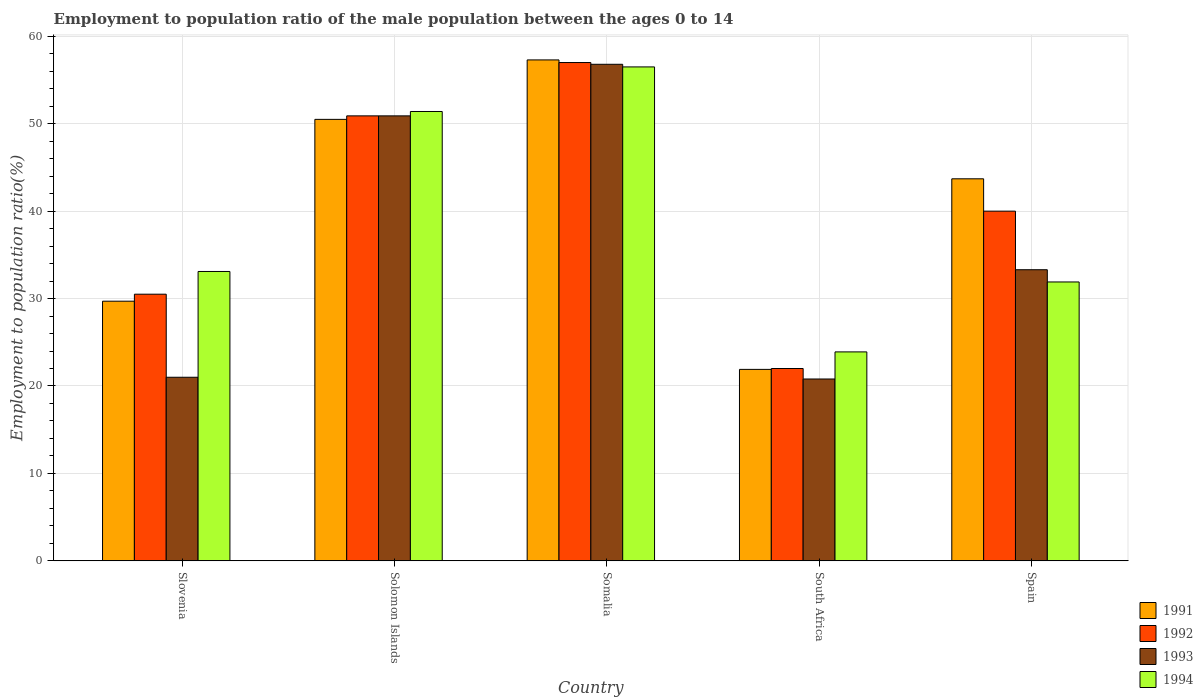Are the number of bars on each tick of the X-axis equal?
Keep it short and to the point. Yes. What is the label of the 1st group of bars from the left?
Ensure brevity in your answer.  Slovenia. Across all countries, what is the maximum employment to population ratio in 1992?
Your response must be concise. 57. Across all countries, what is the minimum employment to population ratio in 1992?
Provide a succinct answer. 22. In which country was the employment to population ratio in 1993 maximum?
Give a very brief answer. Somalia. In which country was the employment to population ratio in 1993 minimum?
Make the answer very short. South Africa. What is the total employment to population ratio in 1994 in the graph?
Provide a succinct answer. 196.8. What is the difference between the employment to population ratio in 1993 in Somalia and that in Spain?
Keep it short and to the point. 23.5. What is the difference between the employment to population ratio in 1993 in Solomon Islands and the employment to population ratio in 1992 in South Africa?
Your response must be concise. 28.9. What is the average employment to population ratio in 1993 per country?
Your response must be concise. 36.56. What is the difference between the employment to population ratio of/in 1991 and employment to population ratio of/in 1993 in Solomon Islands?
Ensure brevity in your answer.  -0.4. In how many countries, is the employment to population ratio in 1992 greater than 52 %?
Provide a short and direct response. 1. What is the ratio of the employment to population ratio in 1994 in Somalia to that in Spain?
Provide a short and direct response. 1.77. Is the employment to population ratio in 1991 in Slovenia less than that in Spain?
Your answer should be very brief. Yes. Is the difference between the employment to population ratio in 1991 in Slovenia and Spain greater than the difference between the employment to population ratio in 1993 in Slovenia and Spain?
Offer a terse response. No. What is the difference between the highest and the lowest employment to population ratio in 1992?
Your answer should be very brief. 35. In how many countries, is the employment to population ratio in 1991 greater than the average employment to population ratio in 1991 taken over all countries?
Provide a short and direct response. 3. What does the 1st bar from the left in Slovenia represents?
Ensure brevity in your answer.  1991. Is it the case that in every country, the sum of the employment to population ratio in 1991 and employment to population ratio in 1994 is greater than the employment to population ratio in 1992?
Keep it short and to the point. Yes. How many bars are there?
Your response must be concise. 20. How many countries are there in the graph?
Offer a very short reply. 5. What is the difference between two consecutive major ticks on the Y-axis?
Give a very brief answer. 10. Does the graph contain any zero values?
Your response must be concise. No. How many legend labels are there?
Offer a very short reply. 4. How are the legend labels stacked?
Ensure brevity in your answer.  Vertical. What is the title of the graph?
Keep it short and to the point. Employment to population ratio of the male population between the ages 0 to 14. Does "1987" appear as one of the legend labels in the graph?
Your response must be concise. No. What is the label or title of the X-axis?
Provide a succinct answer. Country. What is the label or title of the Y-axis?
Give a very brief answer. Employment to population ratio(%). What is the Employment to population ratio(%) of 1991 in Slovenia?
Keep it short and to the point. 29.7. What is the Employment to population ratio(%) in 1992 in Slovenia?
Offer a very short reply. 30.5. What is the Employment to population ratio(%) in 1994 in Slovenia?
Provide a succinct answer. 33.1. What is the Employment to population ratio(%) in 1991 in Solomon Islands?
Provide a short and direct response. 50.5. What is the Employment to population ratio(%) in 1992 in Solomon Islands?
Provide a succinct answer. 50.9. What is the Employment to population ratio(%) of 1993 in Solomon Islands?
Give a very brief answer. 50.9. What is the Employment to population ratio(%) in 1994 in Solomon Islands?
Make the answer very short. 51.4. What is the Employment to population ratio(%) of 1991 in Somalia?
Your response must be concise. 57.3. What is the Employment to population ratio(%) in 1993 in Somalia?
Your answer should be compact. 56.8. What is the Employment to population ratio(%) in 1994 in Somalia?
Offer a terse response. 56.5. What is the Employment to population ratio(%) in 1991 in South Africa?
Your response must be concise. 21.9. What is the Employment to population ratio(%) in 1993 in South Africa?
Offer a terse response. 20.8. What is the Employment to population ratio(%) of 1994 in South Africa?
Your response must be concise. 23.9. What is the Employment to population ratio(%) in 1991 in Spain?
Offer a very short reply. 43.7. What is the Employment to population ratio(%) of 1993 in Spain?
Provide a short and direct response. 33.3. What is the Employment to population ratio(%) of 1994 in Spain?
Offer a very short reply. 31.9. Across all countries, what is the maximum Employment to population ratio(%) in 1991?
Ensure brevity in your answer.  57.3. Across all countries, what is the maximum Employment to population ratio(%) in 1992?
Make the answer very short. 57. Across all countries, what is the maximum Employment to population ratio(%) of 1993?
Make the answer very short. 56.8. Across all countries, what is the maximum Employment to population ratio(%) in 1994?
Ensure brevity in your answer.  56.5. Across all countries, what is the minimum Employment to population ratio(%) in 1991?
Make the answer very short. 21.9. Across all countries, what is the minimum Employment to population ratio(%) of 1992?
Give a very brief answer. 22. Across all countries, what is the minimum Employment to population ratio(%) in 1993?
Provide a succinct answer. 20.8. Across all countries, what is the minimum Employment to population ratio(%) in 1994?
Give a very brief answer. 23.9. What is the total Employment to population ratio(%) of 1991 in the graph?
Your answer should be very brief. 203.1. What is the total Employment to population ratio(%) in 1992 in the graph?
Offer a terse response. 200.4. What is the total Employment to population ratio(%) in 1993 in the graph?
Keep it short and to the point. 182.8. What is the total Employment to population ratio(%) in 1994 in the graph?
Offer a terse response. 196.8. What is the difference between the Employment to population ratio(%) in 1991 in Slovenia and that in Solomon Islands?
Keep it short and to the point. -20.8. What is the difference between the Employment to population ratio(%) in 1992 in Slovenia and that in Solomon Islands?
Provide a short and direct response. -20.4. What is the difference between the Employment to population ratio(%) in 1993 in Slovenia and that in Solomon Islands?
Your answer should be compact. -29.9. What is the difference between the Employment to population ratio(%) of 1994 in Slovenia and that in Solomon Islands?
Make the answer very short. -18.3. What is the difference between the Employment to population ratio(%) in 1991 in Slovenia and that in Somalia?
Offer a very short reply. -27.6. What is the difference between the Employment to population ratio(%) in 1992 in Slovenia and that in Somalia?
Ensure brevity in your answer.  -26.5. What is the difference between the Employment to population ratio(%) in 1993 in Slovenia and that in Somalia?
Make the answer very short. -35.8. What is the difference between the Employment to population ratio(%) of 1994 in Slovenia and that in Somalia?
Your answer should be compact. -23.4. What is the difference between the Employment to population ratio(%) of 1991 in Slovenia and that in South Africa?
Your response must be concise. 7.8. What is the difference between the Employment to population ratio(%) in 1992 in Slovenia and that in South Africa?
Offer a very short reply. 8.5. What is the difference between the Employment to population ratio(%) in 1993 in Slovenia and that in South Africa?
Offer a very short reply. 0.2. What is the difference between the Employment to population ratio(%) in 1994 in Slovenia and that in South Africa?
Your response must be concise. 9.2. What is the difference between the Employment to population ratio(%) in 1991 in Slovenia and that in Spain?
Offer a terse response. -14. What is the difference between the Employment to population ratio(%) of 1992 in Slovenia and that in Spain?
Offer a very short reply. -9.5. What is the difference between the Employment to population ratio(%) of 1994 in Slovenia and that in Spain?
Ensure brevity in your answer.  1.2. What is the difference between the Employment to population ratio(%) of 1991 in Solomon Islands and that in Somalia?
Offer a very short reply. -6.8. What is the difference between the Employment to population ratio(%) of 1991 in Solomon Islands and that in South Africa?
Make the answer very short. 28.6. What is the difference between the Employment to population ratio(%) in 1992 in Solomon Islands and that in South Africa?
Give a very brief answer. 28.9. What is the difference between the Employment to population ratio(%) in 1993 in Solomon Islands and that in South Africa?
Your answer should be very brief. 30.1. What is the difference between the Employment to population ratio(%) of 1994 in Solomon Islands and that in South Africa?
Offer a very short reply. 27.5. What is the difference between the Employment to population ratio(%) in 1991 in Solomon Islands and that in Spain?
Provide a succinct answer. 6.8. What is the difference between the Employment to population ratio(%) in 1992 in Solomon Islands and that in Spain?
Keep it short and to the point. 10.9. What is the difference between the Employment to population ratio(%) of 1994 in Solomon Islands and that in Spain?
Your response must be concise. 19.5. What is the difference between the Employment to population ratio(%) in 1991 in Somalia and that in South Africa?
Make the answer very short. 35.4. What is the difference between the Employment to population ratio(%) of 1993 in Somalia and that in South Africa?
Ensure brevity in your answer.  36. What is the difference between the Employment to population ratio(%) in 1994 in Somalia and that in South Africa?
Your answer should be very brief. 32.6. What is the difference between the Employment to population ratio(%) of 1991 in Somalia and that in Spain?
Give a very brief answer. 13.6. What is the difference between the Employment to population ratio(%) of 1992 in Somalia and that in Spain?
Provide a short and direct response. 17. What is the difference between the Employment to population ratio(%) in 1994 in Somalia and that in Spain?
Ensure brevity in your answer.  24.6. What is the difference between the Employment to population ratio(%) of 1991 in South Africa and that in Spain?
Ensure brevity in your answer.  -21.8. What is the difference between the Employment to population ratio(%) of 1991 in Slovenia and the Employment to population ratio(%) of 1992 in Solomon Islands?
Offer a very short reply. -21.2. What is the difference between the Employment to population ratio(%) in 1991 in Slovenia and the Employment to population ratio(%) in 1993 in Solomon Islands?
Make the answer very short. -21.2. What is the difference between the Employment to population ratio(%) in 1991 in Slovenia and the Employment to population ratio(%) in 1994 in Solomon Islands?
Keep it short and to the point. -21.7. What is the difference between the Employment to population ratio(%) of 1992 in Slovenia and the Employment to population ratio(%) of 1993 in Solomon Islands?
Your answer should be very brief. -20.4. What is the difference between the Employment to population ratio(%) in 1992 in Slovenia and the Employment to population ratio(%) in 1994 in Solomon Islands?
Offer a very short reply. -20.9. What is the difference between the Employment to population ratio(%) in 1993 in Slovenia and the Employment to population ratio(%) in 1994 in Solomon Islands?
Provide a short and direct response. -30.4. What is the difference between the Employment to population ratio(%) of 1991 in Slovenia and the Employment to population ratio(%) of 1992 in Somalia?
Offer a very short reply. -27.3. What is the difference between the Employment to population ratio(%) in 1991 in Slovenia and the Employment to population ratio(%) in 1993 in Somalia?
Offer a very short reply. -27.1. What is the difference between the Employment to population ratio(%) of 1991 in Slovenia and the Employment to population ratio(%) of 1994 in Somalia?
Give a very brief answer. -26.8. What is the difference between the Employment to population ratio(%) of 1992 in Slovenia and the Employment to population ratio(%) of 1993 in Somalia?
Ensure brevity in your answer.  -26.3. What is the difference between the Employment to population ratio(%) in 1992 in Slovenia and the Employment to population ratio(%) in 1994 in Somalia?
Offer a terse response. -26. What is the difference between the Employment to population ratio(%) in 1993 in Slovenia and the Employment to population ratio(%) in 1994 in Somalia?
Make the answer very short. -35.5. What is the difference between the Employment to population ratio(%) of 1991 in Slovenia and the Employment to population ratio(%) of 1993 in South Africa?
Provide a short and direct response. 8.9. What is the difference between the Employment to population ratio(%) in 1992 in Slovenia and the Employment to population ratio(%) in 1993 in South Africa?
Offer a very short reply. 9.7. What is the difference between the Employment to population ratio(%) of 1991 in Slovenia and the Employment to population ratio(%) of 1992 in Spain?
Your answer should be very brief. -10.3. What is the difference between the Employment to population ratio(%) in 1991 in Slovenia and the Employment to population ratio(%) in 1993 in Spain?
Provide a short and direct response. -3.6. What is the difference between the Employment to population ratio(%) of 1991 in Slovenia and the Employment to population ratio(%) of 1994 in Spain?
Provide a short and direct response. -2.2. What is the difference between the Employment to population ratio(%) of 1991 in Solomon Islands and the Employment to population ratio(%) of 1992 in Somalia?
Make the answer very short. -6.5. What is the difference between the Employment to population ratio(%) in 1991 in Solomon Islands and the Employment to population ratio(%) in 1994 in Somalia?
Your answer should be compact. -6. What is the difference between the Employment to population ratio(%) of 1991 in Solomon Islands and the Employment to population ratio(%) of 1993 in South Africa?
Provide a short and direct response. 29.7. What is the difference between the Employment to population ratio(%) in 1991 in Solomon Islands and the Employment to population ratio(%) in 1994 in South Africa?
Your answer should be compact. 26.6. What is the difference between the Employment to population ratio(%) of 1992 in Solomon Islands and the Employment to population ratio(%) of 1993 in South Africa?
Keep it short and to the point. 30.1. What is the difference between the Employment to population ratio(%) of 1992 in Solomon Islands and the Employment to population ratio(%) of 1994 in South Africa?
Your answer should be very brief. 27. What is the difference between the Employment to population ratio(%) of 1993 in Solomon Islands and the Employment to population ratio(%) of 1994 in South Africa?
Your response must be concise. 27. What is the difference between the Employment to population ratio(%) in 1991 in Solomon Islands and the Employment to population ratio(%) in 1992 in Spain?
Make the answer very short. 10.5. What is the difference between the Employment to population ratio(%) in 1993 in Solomon Islands and the Employment to population ratio(%) in 1994 in Spain?
Your answer should be compact. 19. What is the difference between the Employment to population ratio(%) of 1991 in Somalia and the Employment to population ratio(%) of 1992 in South Africa?
Give a very brief answer. 35.3. What is the difference between the Employment to population ratio(%) in 1991 in Somalia and the Employment to population ratio(%) in 1993 in South Africa?
Provide a succinct answer. 36.5. What is the difference between the Employment to population ratio(%) of 1991 in Somalia and the Employment to population ratio(%) of 1994 in South Africa?
Your answer should be very brief. 33.4. What is the difference between the Employment to population ratio(%) in 1992 in Somalia and the Employment to population ratio(%) in 1993 in South Africa?
Offer a very short reply. 36.2. What is the difference between the Employment to population ratio(%) in 1992 in Somalia and the Employment to population ratio(%) in 1994 in South Africa?
Provide a succinct answer. 33.1. What is the difference between the Employment to population ratio(%) of 1993 in Somalia and the Employment to population ratio(%) of 1994 in South Africa?
Offer a terse response. 32.9. What is the difference between the Employment to population ratio(%) in 1991 in Somalia and the Employment to population ratio(%) in 1992 in Spain?
Your response must be concise. 17.3. What is the difference between the Employment to population ratio(%) of 1991 in Somalia and the Employment to population ratio(%) of 1994 in Spain?
Provide a succinct answer. 25.4. What is the difference between the Employment to population ratio(%) in 1992 in Somalia and the Employment to population ratio(%) in 1993 in Spain?
Offer a very short reply. 23.7. What is the difference between the Employment to population ratio(%) of 1992 in Somalia and the Employment to population ratio(%) of 1994 in Spain?
Provide a short and direct response. 25.1. What is the difference between the Employment to population ratio(%) of 1993 in Somalia and the Employment to population ratio(%) of 1994 in Spain?
Offer a terse response. 24.9. What is the difference between the Employment to population ratio(%) of 1991 in South Africa and the Employment to population ratio(%) of 1992 in Spain?
Offer a very short reply. -18.1. What is the difference between the Employment to population ratio(%) in 1991 in South Africa and the Employment to population ratio(%) in 1994 in Spain?
Provide a short and direct response. -10. What is the difference between the Employment to population ratio(%) in 1992 in South Africa and the Employment to population ratio(%) in 1993 in Spain?
Ensure brevity in your answer.  -11.3. What is the difference between the Employment to population ratio(%) in 1993 in South Africa and the Employment to population ratio(%) in 1994 in Spain?
Your response must be concise. -11.1. What is the average Employment to population ratio(%) in 1991 per country?
Your answer should be very brief. 40.62. What is the average Employment to population ratio(%) of 1992 per country?
Keep it short and to the point. 40.08. What is the average Employment to population ratio(%) of 1993 per country?
Keep it short and to the point. 36.56. What is the average Employment to population ratio(%) in 1994 per country?
Offer a terse response. 39.36. What is the difference between the Employment to population ratio(%) of 1991 and Employment to population ratio(%) of 1992 in Slovenia?
Offer a very short reply. -0.8. What is the difference between the Employment to population ratio(%) of 1992 and Employment to population ratio(%) of 1993 in Slovenia?
Provide a short and direct response. 9.5. What is the difference between the Employment to population ratio(%) in 1992 and Employment to population ratio(%) in 1994 in Slovenia?
Provide a short and direct response. -2.6. What is the difference between the Employment to population ratio(%) of 1993 and Employment to population ratio(%) of 1994 in Slovenia?
Make the answer very short. -12.1. What is the difference between the Employment to population ratio(%) of 1991 and Employment to population ratio(%) of 1992 in Solomon Islands?
Your answer should be compact. -0.4. What is the difference between the Employment to population ratio(%) in 1991 and Employment to population ratio(%) in 1993 in Solomon Islands?
Your answer should be very brief. -0.4. What is the difference between the Employment to population ratio(%) of 1992 and Employment to population ratio(%) of 1993 in Solomon Islands?
Ensure brevity in your answer.  0. What is the difference between the Employment to population ratio(%) in 1992 and Employment to population ratio(%) in 1994 in Solomon Islands?
Your response must be concise. -0.5. What is the difference between the Employment to population ratio(%) in 1993 and Employment to population ratio(%) in 1994 in Solomon Islands?
Your answer should be compact. -0.5. What is the difference between the Employment to population ratio(%) in 1991 and Employment to population ratio(%) in 1994 in Somalia?
Ensure brevity in your answer.  0.8. What is the difference between the Employment to population ratio(%) of 1992 and Employment to population ratio(%) of 1994 in Somalia?
Ensure brevity in your answer.  0.5. What is the difference between the Employment to population ratio(%) of 1993 and Employment to population ratio(%) of 1994 in Somalia?
Offer a terse response. 0.3. What is the difference between the Employment to population ratio(%) in 1991 and Employment to population ratio(%) in 1992 in South Africa?
Offer a terse response. -0.1. What is the difference between the Employment to population ratio(%) of 1991 and Employment to population ratio(%) of 1993 in South Africa?
Your response must be concise. 1.1. What is the difference between the Employment to population ratio(%) in 1993 and Employment to population ratio(%) in 1994 in South Africa?
Offer a very short reply. -3.1. What is the difference between the Employment to population ratio(%) in 1992 and Employment to population ratio(%) in 1993 in Spain?
Offer a terse response. 6.7. What is the difference between the Employment to population ratio(%) in 1993 and Employment to population ratio(%) in 1994 in Spain?
Keep it short and to the point. 1.4. What is the ratio of the Employment to population ratio(%) in 1991 in Slovenia to that in Solomon Islands?
Ensure brevity in your answer.  0.59. What is the ratio of the Employment to population ratio(%) in 1992 in Slovenia to that in Solomon Islands?
Give a very brief answer. 0.6. What is the ratio of the Employment to population ratio(%) of 1993 in Slovenia to that in Solomon Islands?
Your answer should be very brief. 0.41. What is the ratio of the Employment to population ratio(%) in 1994 in Slovenia to that in Solomon Islands?
Ensure brevity in your answer.  0.64. What is the ratio of the Employment to population ratio(%) in 1991 in Slovenia to that in Somalia?
Your response must be concise. 0.52. What is the ratio of the Employment to population ratio(%) in 1992 in Slovenia to that in Somalia?
Your response must be concise. 0.54. What is the ratio of the Employment to population ratio(%) in 1993 in Slovenia to that in Somalia?
Give a very brief answer. 0.37. What is the ratio of the Employment to population ratio(%) in 1994 in Slovenia to that in Somalia?
Keep it short and to the point. 0.59. What is the ratio of the Employment to population ratio(%) of 1991 in Slovenia to that in South Africa?
Offer a very short reply. 1.36. What is the ratio of the Employment to population ratio(%) in 1992 in Slovenia to that in South Africa?
Your answer should be compact. 1.39. What is the ratio of the Employment to population ratio(%) of 1993 in Slovenia to that in South Africa?
Your answer should be compact. 1.01. What is the ratio of the Employment to population ratio(%) in 1994 in Slovenia to that in South Africa?
Your answer should be very brief. 1.38. What is the ratio of the Employment to population ratio(%) in 1991 in Slovenia to that in Spain?
Your response must be concise. 0.68. What is the ratio of the Employment to population ratio(%) of 1992 in Slovenia to that in Spain?
Keep it short and to the point. 0.76. What is the ratio of the Employment to population ratio(%) in 1993 in Slovenia to that in Spain?
Your answer should be compact. 0.63. What is the ratio of the Employment to population ratio(%) in 1994 in Slovenia to that in Spain?
Provide a short and direct response. 1.04. What is the ratio of the Employment to population ratio(%) of 1991 in Solomon Islands to that in Somalia?
Give a very brief answer. 0.88. What is the ratio of the Employment to population ratio(%) of 1992 in Solomon Islands to that in Somalia?
Offer a terse response. 0.89. What is the ratio of the Employment to population ratio(%) of 1993 in Solomon Islands to that in Somalia?
Provide a short and direct response. 0.9. What is the ratio of the Employment to population ratio(%) of 1994 in Solomon Islands to that in Somalia?
Your response must be concise. 0.91. What is the ratio of the Employment to population ratio(%) of 1991 in Solomon Islands to that in South Africa?
Your answer should be compact. 2.31. What is the ratio of the Employment to population ratio(%) in 1992 in Solomon Islands to that in South Africa?
Your answer should be compact. 2.31. What is the ratio of the Employment to population ratio(%) of 1993 in Solomon Islands to that in South Africa?
Your answer should be very brief. 2.45. What is the ratio of the Employment to population ratio(%) of 1994 in Solomon Islands to that in South Africa?
Your answer should be compact. 2.15. What is the ratio of the Employment to population ratio(%) of 1991 in Solomon Islands to that in Spain?
Your answer should be compact. 1.16. What is the ratio of the Employment to population ratio(%) of 1992 in Solomon Islands to that in Spain?
Give a very brief answer. 1.27. What is the ratio of the Employment to population ratio(%) of 1993 in Solomon Islands to that in Spain?
Provide a short and direct response. 1.53. What is the ratio of the Employment to population ratio(%) in 1994 in Solomon Islands to that in Spain?
Your answer should be compact. 1.61. What is the ratio of the Employment to population ratio(%) in 1991 in Somalia to that in South Africa?
Keep it short and to the point. 2.62. What is the ratio of the Employment to population ratio(%) in 1992 in Somalia to that in South Africa?
Your answer should be very brief. 2.59. What is the ratio of the Employment to population ratio(%) in 1993 in Somalia to that in South Africa?
Keep it short and to the point. 2.73. What is the ratio of the Employment to population ratio(%) in 1994 in Somalia to that in South Africa?
Ensure brevity in your answer.  2.36. What is the ratio of the Employment to population ratio(%) of 1991 in Somalia to that in Spain?
Provide a short and direct response. 1.31. What is the ratio of the Employment to population ratio(%) of 1992 in Somalia to that in Spain?
Your response must be concise. 1.43. What is the ratio of the Employment to population ratio(%) of 1993 in Somalia to that in Spain?
Keep it short and to the point. 1.71. What is the ratio of the Employment to population ratio(%) in 1994 in Somalia to that in Spain?
Provide a short and direct response. 1.77. What is the ratio of the Employment to population ratio(%) in 1991 in South Africa to that in Spain?
Offer a very short reply. 0.5. What is the ratio of the Employment to population ratio(%) of 1992 in South Africa to that in Spain?
Give a very brief answer. 0.55. What is the ratio of the Employment to population ratio(%) in 1993 in South Africa to that in Spain?
Give a very brief answer. 0.62. What is the ratio of the Employment to population ratio(%) in 1994 in South Africa to that in Spain?
Offer a terse response. 0.75. What is the difference between the highest and the second highest Employment to population ratio(%) in 1991?
Keep it short and to the point. 6.8. What is the difference between the highest and the second highest Employment to population ratio(%) of 1994?
Provide a succinct answer. 5.1. What is the difference between the highest and the lowest Employment to population ratio(%) of 1991?
Keep it short and to the point. 35.4. What is the difference between the highest and the lowest Employment to population ratio(%) in 1992?
Provide a succinct answer. 35. What is the difference between the highest and the lowest Employment to population ratio(%) in 1994?
Your response must be concise. 32.6. 